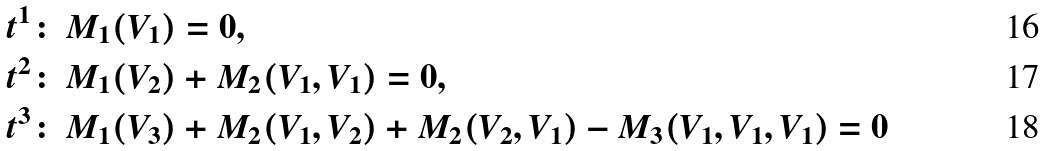<formula> <loc_0><loc_0><loc_500><loc_500>t ^ { 1 } \colon \, & M _ { 1 } ( V _ { 1 } ) = 0 , \\ t ^ { 2 } \colon \, & M _ { 1 } ( V _ { 2 } ) + M _ { 2 } ( V _ { 1 } , V _ { 1 } ) = 0 , \\ t ^ { 3 } \colon \, & M _ { 1 } ( V _ { 3 } ) + M _ { 2 } ( V _ { 1 } , V _ { 2 } ) + M _ { 2 } ( V _ { 2 } , V _ { 1 } ) - M _ { 3 } ( V _ { 1 } , V _ { 1 } , V _ { 1 } ) = 0</formula> 